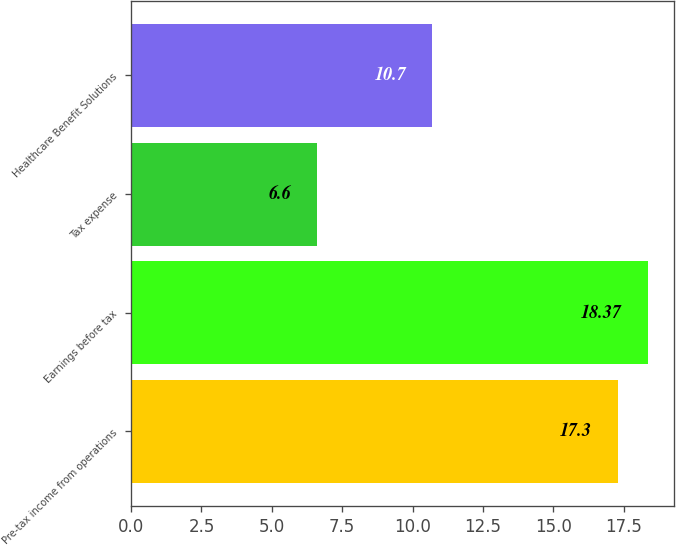Convert chart to OTSL. <chart><loc_0><loc_0><loc_500><loc_500><bar_chart><fcel>Pre-tax income from operations<fcel>Earnings before tax<fcel>Tax expense<fcel>Healthcare Benefit Solutions<nl><fcel>17.3<fcel>18.37<fcel>6.6<fcel>10.7<nl></chart> 